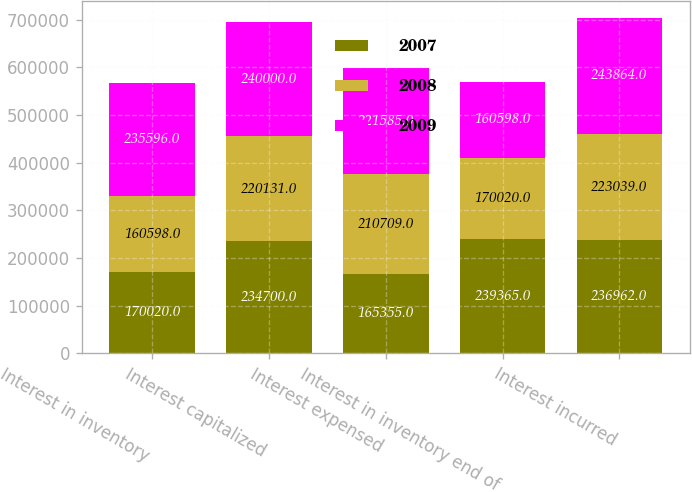Convert chart. <chart><loc_0><loc_0><loc_500><loc_500><stacked_bar_chart><ecel><fcel>Interest in inventory<fcel>Interest capitalized<fcel>Interest expensed<fcel>Interest in inventory end of<fcel>Interest incurred<nl><fcel>2007<fcel>170020<fcel>234700<fcel>165355<fcel>239365<fcel>236962<nl><fcel>2008<fcel>160598<fcel>220131<fcel>210709<fcel>170020<fcel>223039<nl><fcel>2009<fcel>235596<fcel>240000<fcel>221585<fcel>160598<fcel>243864<nl></chart> 